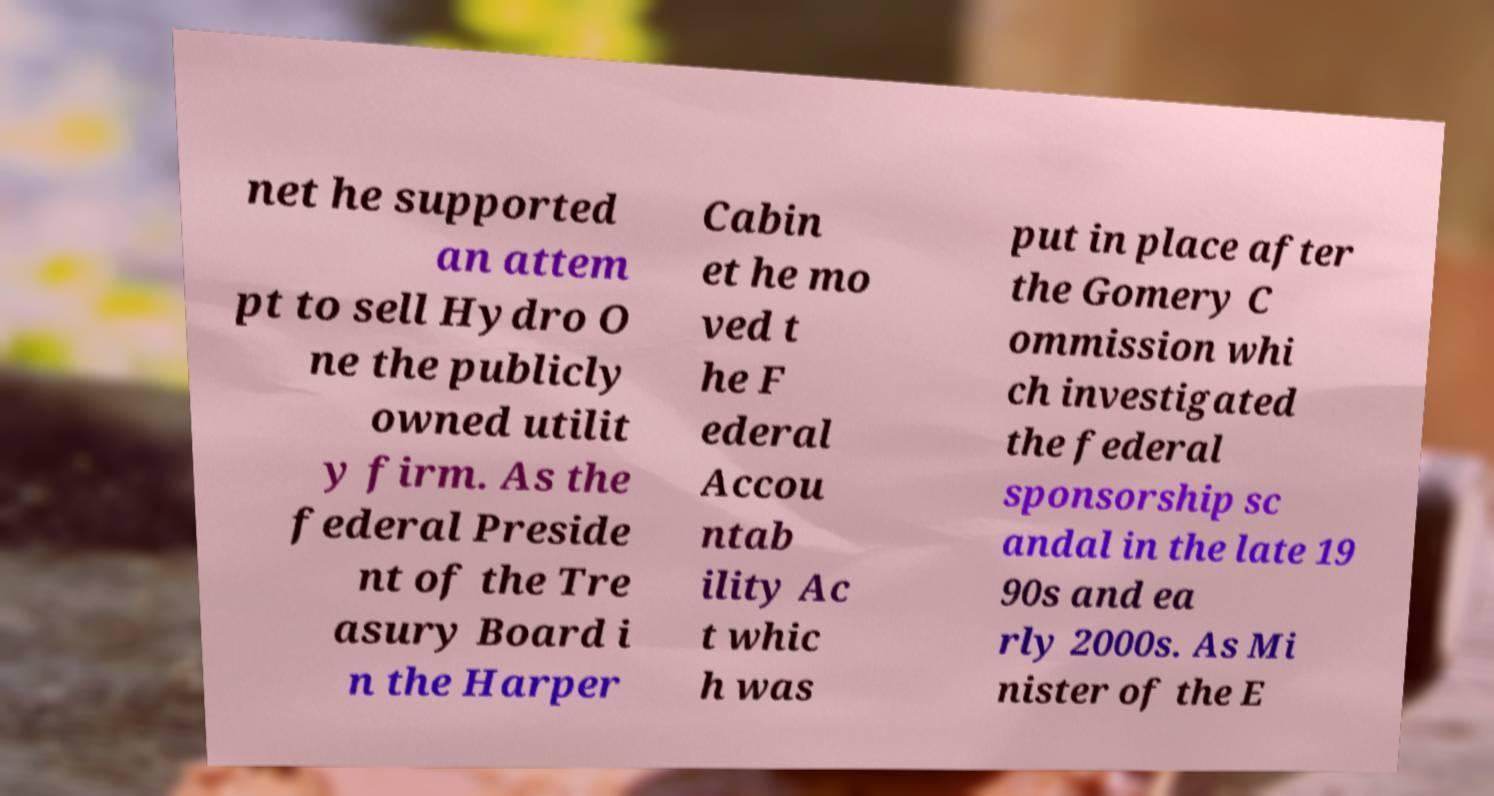For documentation purposes, I need the text within this image transcribed. Could you provide that? net he supported an attem pt to sell Hydro O ne the publicly owned utilit y firm. As the federal Preside nt of the Tre asury Board i n the Harper Cabin et he mo ved t he F ederal Accou ntab ility Ac t whic h was put in place after the Gomery C ommission whi ch investigated the federal sponsorship sc andal in the late 19 90s and ea rly 2000s. As Mi nister of the E 